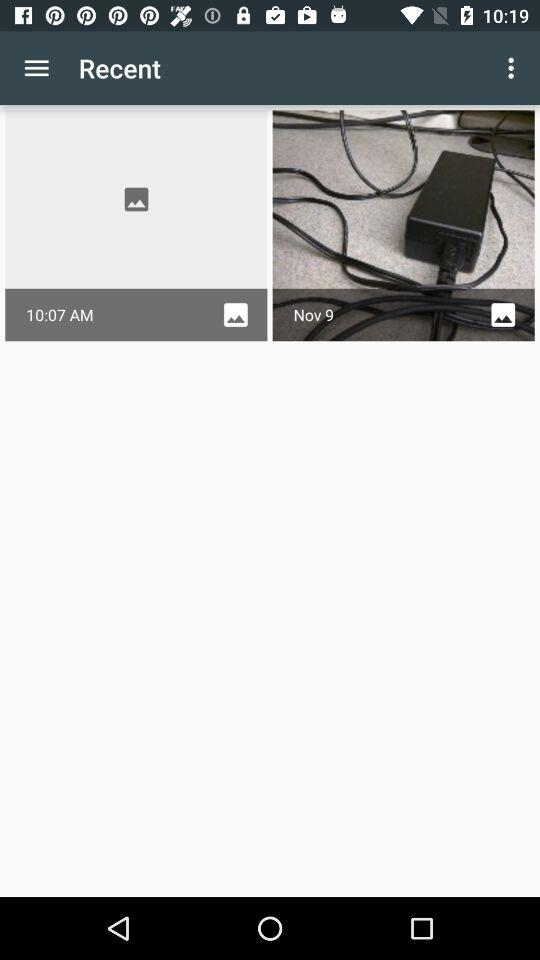Who posted the images?
When the provided information is insufficient, respond with <no answer>. <no answer> 